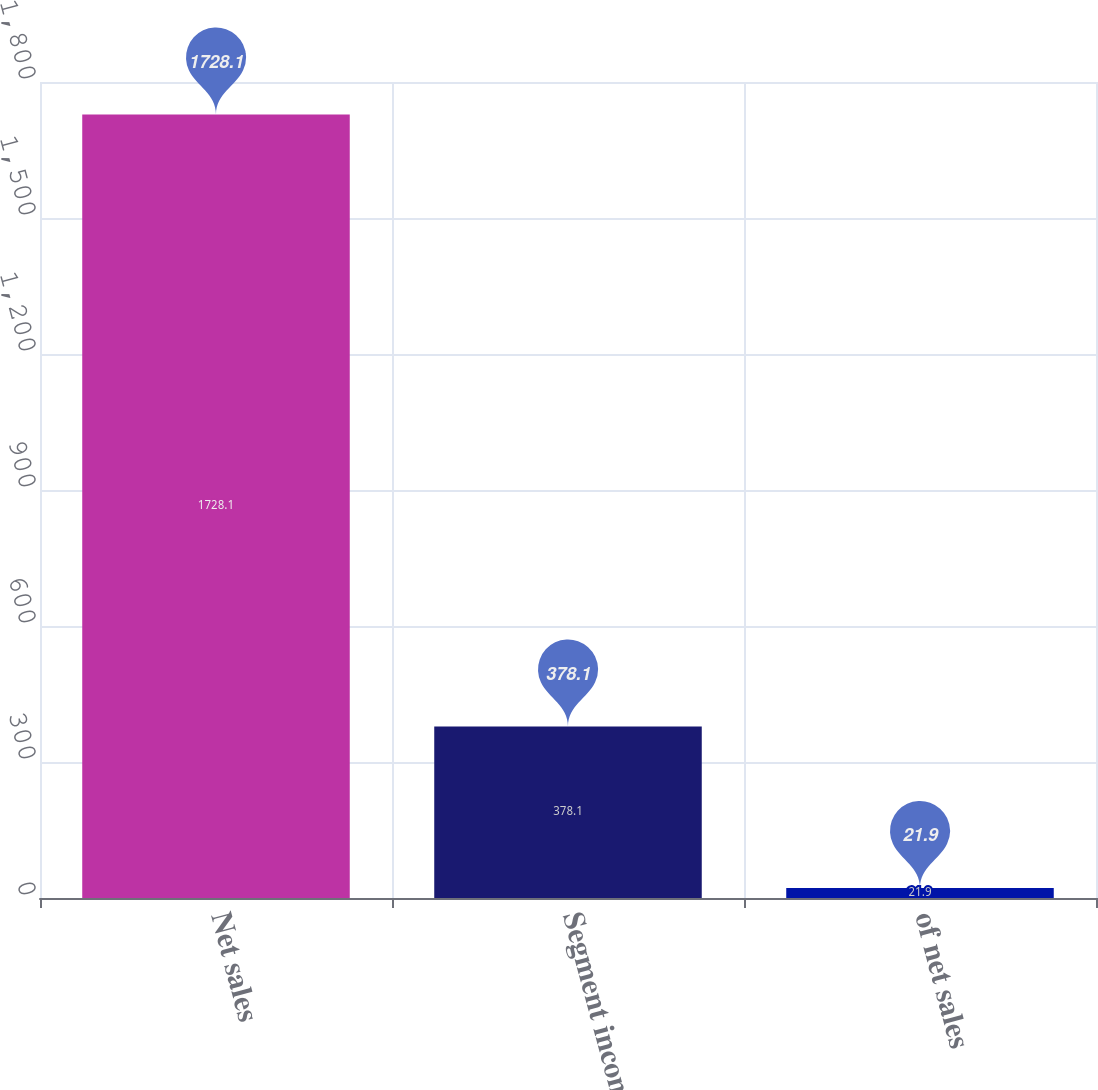<chart> <loc_0><loc_0><loc_500><loc_500><bar_chart><fcel>Net sales<fcel>Segment income<fcel>of net sales<nl><fcel>1728.1<fcel>378.1<fcel>21.9<nl></chart> 